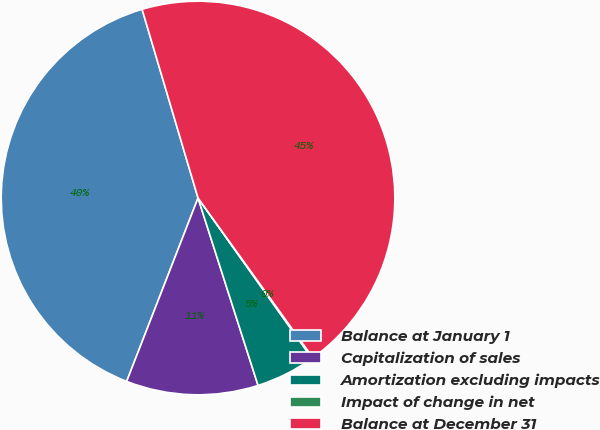Convert chart. <chart><loc_0><loc_0><loc_500><loc_500><pie_chart><fcel>Balance at January 1<fcel>Capitalization of sales<fcel>Amortization excluding impacts<fcel>Impact of change in net<fcel>Balance at December 31<nl><fcel>39.51%<fcel>10.84%<fcel>4.9%<fcel>0.09%<fcel>44.67%<nl></chart> 